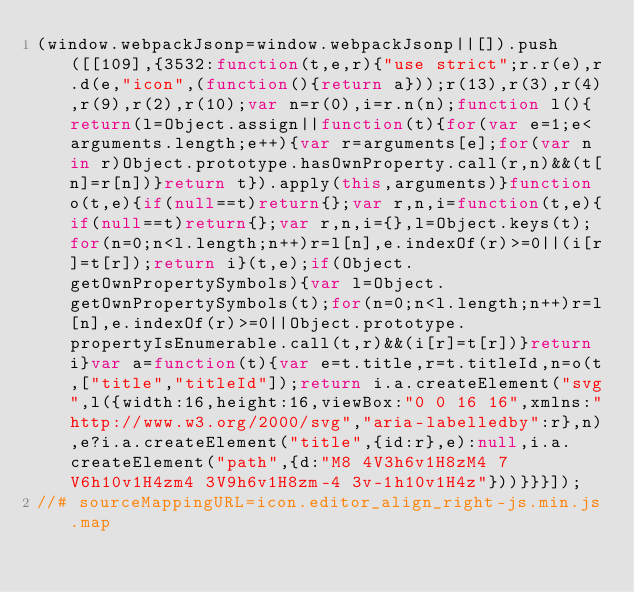Convert code to text. <code><loc_0><loc_0><loc_500><loc_500><_JavaScript_>(window.webpackJsonp=window.webpackJsonp||[]).push([[109],{3532:function(t,e,r){"use strict";r.r(e),r.d(e,"icon",(function(){return a}));r(13),r(3),r(4),r(9),r(2),r(10);var n=r(0),i=r.n(n);function l(){return(l=Object.assign||function(t){for(var e=1;e<arguments.length;e++){var r=arguments[e];for(var n in r)Object.prototype.hasOwnProperty.call(r,n)&&(t[n]=r[n])}return t}).apply(this,arguments)}function o(t,e){if(null==t)return{};var r,n,i=function(t,e){if(null==t)return{};var r,n,i={},l=Object.keys(t);for(n=0;n<l.length;n++)r=l[n],e.indexOf(r)>=0||(i[r]=t[r]);return i}(t,e);if(Object.getOwnPropertySymbols){var l=Object.getOwnPropertySymbols(t);for(n=0;n<l.length;n++)r=l[n],e.indexOf(r)>=0||Object.prototype.propertyIsEnumerable.call(t,r)&&(i[r]=t[r])}return i}var a=function(t){var e=t.title,r=t.titleId,n=o(t,["title","titleId"]);return i.a.createElement("svg",l({width:16,height:16,viewBox:"0 0 16 16",xmlns:"http://www.w3.org/2000/svg","aria-labelledby":r},n),e?i.a.createElement("title",{id:r},e):null,i.a.createElement("path",{d:"M8 4V3h6v1H8zM4 7V6h10v1H4zm4 3V9h6v1H8zm-4 3v-1h10v1H4z"}))}}}]);
//# sourceMappingURL=icon.editor_align_right-js.min.js.map</code> 